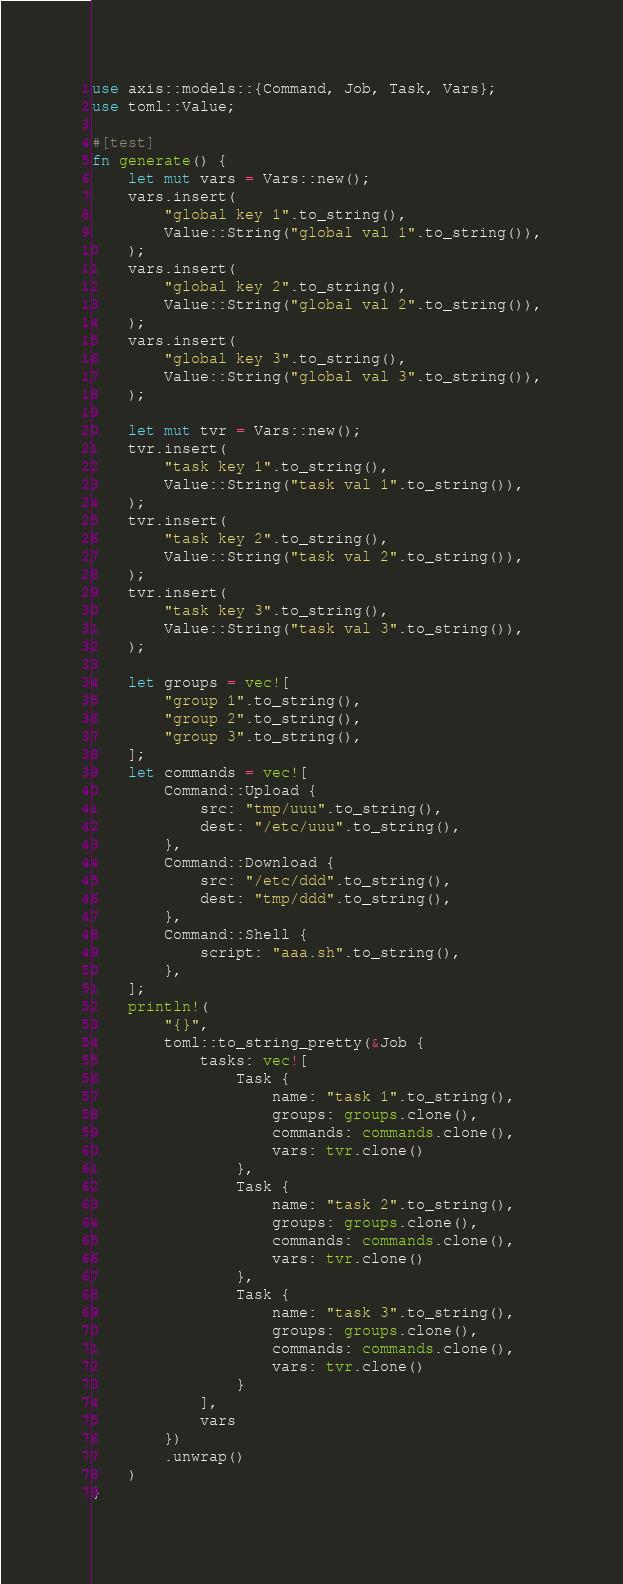Convert code to text. <code><loc_0><loc_0><loc_500><loc_500><_Rust_>use axis::models::{Command, Job, Task, Vars};
use toml::Value;

#[test]
fn generate() {
    let mut vars = Vars::new();
    vars.insert(
        "global key 1".to_string(),
        Value::String("global val 1".to_string()),
    );
    vars.insert(
        "global key 2".to_string(),
        Value::String("global val 2".to_string()),
    );
    vars.insert(
        "global key 3".to_string(),
        Value::String("global val 3".to_string()),
    );

    let mut tvr = Vars::new();
    tvr.insert(
        "task key 1".to_string(),
        Value::String("task val 1".to_string()),
    );
    tvr.insert(
        "task key 2".to_string(),
        Value::String("task val 2".to_string()),
    );
    tvr.insert(
        "task key 3".to_string(),
        Value::String("task val 3".to_string()),
    );

    let groups = vec![
        "group 1".to_string(),
        "group 2".to_string(),
        "group 3".to_string(),
    ];
    let commands = vec![
        Command::Upload {
            src: "tmp/uuu".to_string(),
            dest: "/etc/uuu".to_string(),
        },
        Command::Download {
            src: "/etc/ddd".to_string(),
            dest: "tmp/ddd".to_string(),
        },
        Command::Shell {
            script: "aaa.sh".to_string(),
        },
    ];
    println!(
        "{}",
        toml::to_string_pretty(&Job {
            tasks: vec![
                Task {
                    name: "task 1".to_string(),
                    groups: groups.clone(),
                    commands: commands.clone(),
                    vars: tvr.clone()
                },
                Task {
                    name: "task 2".to_string(),
                    groups: groups.clone(),
                    commands: commands.clone(),
                    vars: tvr.clone()
                },
                Task {
                    name: "task 3".to_string(),
                    groups: groups.clone(),
                    commands: commands.clone(),
                    vars: tvr.clone()
                }
            ],
            vars
        })
        .unwrap()
    )
}
</code> 